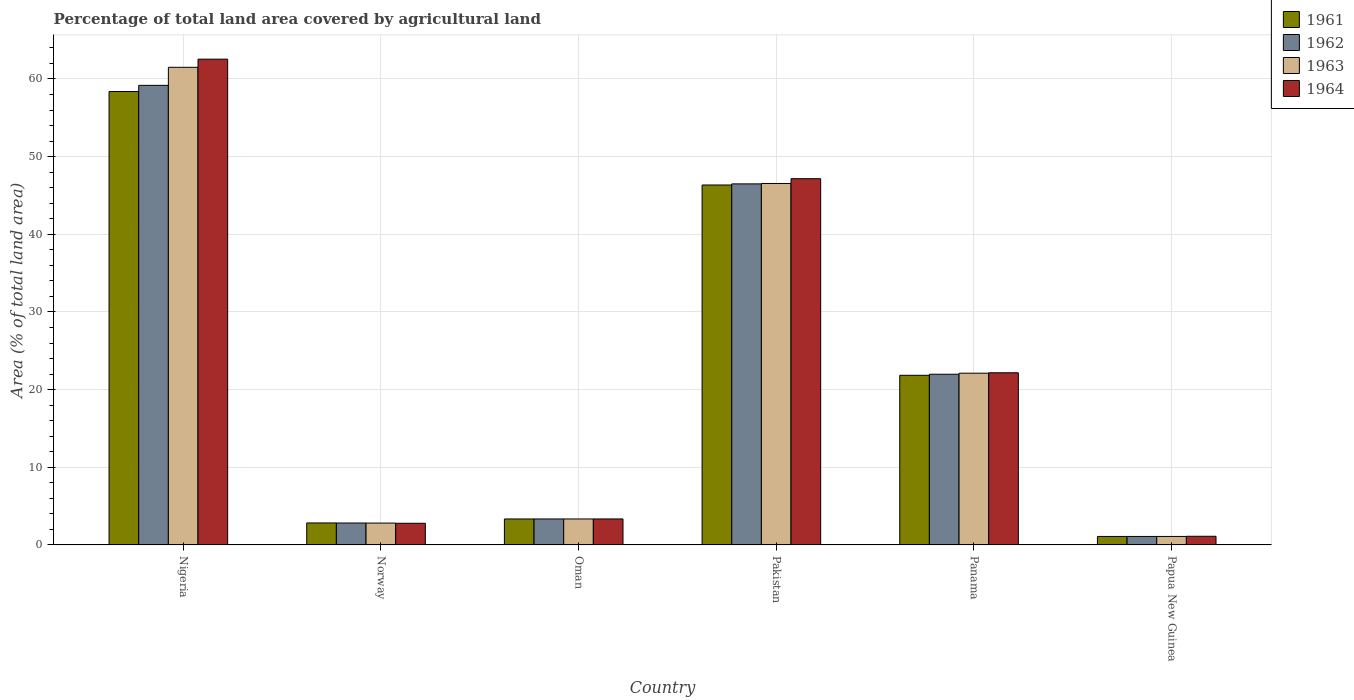How many different coloured bars are there?
Provide a short and direct response. 4. How many bars are there on the 3rd tick from the left?
Offer a terse response. 4. How many bars are there on the 2nd tick from the right?
Ensure brevity in your answer.  4. What is the label of the 6th group of bars from the left?
Your answer should be very brief. Papua New Guinea. What is the percentage of agricultural land in 1962 in Norway?
Ensure brevity in your answer.  2.82. Across all countries, what is the maximum percentage of agricultural land in 1962?
Your answer should be very brief. 59.18. Across all countries, what is the minimum percentage of agricultural land in 1962?
Your answer should be compact. 1.09. In which country was the percentage of agricultural land in 1961 maximum?
Provide a short and direct response. Nigeria. In which country was the percentage of agricultural land in 1962 minimum?
Provide a succinct answer. Papua New Guinea. What is the total percentage of agricultural land in 1963 in the graph?
Provide a succinct answer. 137.42. What is the difference between the percentage of agricultural land in 1961 in Oman and that in Papua New Guinea?
Your answer should be very brief. 2.25. What is the difference between the percentage of agricultural land in 1962 in Nigeria and the percentage of agricultural land in 1961 in Panama?
Ensure brevity in your answer.  37.34. What is the average percentage of agricultural land in 1962 per country?
Your answer should be compact. 22.49. What is the difference between the percentage of agricultural land of/in 1964 and percentage of agricultural land of/in 1963 in Pakistan?
Ensure brevity in your answer.  0.62. What is the ratio of the percentage of agricultural land in 1963 in Oman to that in Pakistan?
Offer a very short reply. 0.07. Is the difference between the percentage of agricultural land in 1964 in Norway and Oman greater than the difference between the percentage of agricultural land in 1963 in Norway and Oman?
Make the answer very short. No. What is the difference between the highest and the second highest percentage of agricultural land in 1962?
Keep it short and to the point. 37.2. What is the difference between the highest and the lowest percentage of agricultural land in 1962?
Offer a very short reply. 58.09. Is it the case that in every country, the sum of the percentage of agricultural land in 1964 and percentage of agricultural land in 1961 is greater than the sum of percentage of agricultural land in 1962 and percentage of agricultural land in 1963?
Make the answer very short. No. What does the 2nd bar from the left in Nigeria represents?
Offer a terse response. 1962. What does the 3rd bar from the right in Oman represents?
Offer a very short reply. 1962. What is the difference between two consecutive major ticks on the Y-axis?
Provide a short and direct response. 10. Are the values on the major ticks of Y-axis written in scientific E-notation?
Make the answer very short. No. Does the graph contain any zero values?
Provide a succinct answer. No. Does the graph contain grids?
Your answer should be compact. Yes. Where does the legend appear in the graph?
Give a very brief answer. Top right. How many legend labels are there?
Provide a succinct answer. 4. What is the title of the graph?
Offer a terse response. Percentage of total land area covered by agricultural land. Does "1972" appear as one of the legend labels in the graph?
Provide a succinct answer. No. What is the label or title of the Y-axis?
Your answer should be very brief. Area (% of total land area). What is the Area (% of total land area) of 1961 in Nigeria?
Your answer should be compact. 58.39. What is the Area (% of total land area) in 1962 in Nigeria?
Give a very brief answer. 59.18. What is the Area (% of total land area) in 1963 in Nigeria?
Offer a very short reply. 61.51. What is the Area (% of total land area) of 1964 in Nigeria?
Your answer should be compact. 62.55. What is the Area (% of total land area) of 1961 in Norway?
Give a very brief answer. 2.83. What is the Area (% of total land area) in 1962 in Norway?
Offer a terse response. 2.82. What is the Area (% of total land area) of 1963 in Norway?
Your answer should be very brief. 2.81. What is the Area (% of total land area) of 1964 in Norway?
Offer a very short reply. 2.79. What is the Area (% of total land area) of 1961 in Oman?
Offer a terse response. 3.34. What is the Area (% of total land area) in 1962 in Oman?
Your response must be concise. 3.34. What is the Area (% of total land area) of 1963 in Oman?
Your answer should be very brief. 3.34. What is the Area (% of total land area) of 1964 in Oman?
Give a very brief answer. 3.35. What is the Area (% of total land area) in 1961 in Pakistan?
Provide a succinct answer. 46.35. What is the Area (% of total land area) in 1962 in Pakistan?
Your answer should be very brief. 46.49. What is the Area (% of total land area) of 1963 in Pakistan?
Your answer should be very brief. 46.54. What is the Area (% of total land area) in 1964 in Pakistan?
Ensure brevity in your answer.  47.16. What is the Area (% of total land area) of 1961 in Panama?
Make the answer very short. 21.85. What is the Area (% of total land area) in 1962 in Panama?
Give a very brief answer. 21.98. What is the Area (% of total land area) in 1963 in Panama?
Your answer should be compact. 22.11. What is the Area (% of total land area) in 1964 in Panama?
Provide a succinct answer. 22.17. What is the Area (% of total land area) of 1961 in Papua New Guinea?
Offer a very short reply. 1.09. What is the Area (% of total land area) in 1962 in Papua New Guinea?
Keep it short and to the point. 1.09. What is the Area (% of total land area) of 1963 in Papua New Guinea?
Your answer should be very brief. 1.09. What is the Area (% of total land area) of 1964 in Papua New Guinea?
Your answer should be very brief. 1.12. Across all countries, what is the maximum Area (% of total land area) of 1961?
Offer a terse response. 58.39. Across all countries, what is the maximum Area (% of total land area) in 1962?
Provide a short and direct response. 59.18. Across all countries, what is the maximum Area (% of total land area) in 1963?
Keep it short and to the point. 61.51. Across all countries, what is the maximum Area (% of total land area) of 1964?
Make the answer very short. 62.55. Across all countries, what is the minimum Area (% of total land area) of 1961?
Keep it short and to the point. 1.09. Across all countries, what is the minimum Area (% of total land area) in 1962?
Your response must be concise. 1.09. Across all countries, what is the minimum Area (% of total land area) of 1963?
Ensure brevity in your answer.  1.09. Across all countries, what is the minimum Area (% of total land area) in 1964?
Give a very brief answer. 1.12. What is the total Area (% of total land area) in 1961 in the graph?
Ensure brevity in your answer.  133.85. What is the total Area (% of total land area) in 1962 in the graph?
Your response must be concise. 134.91. What is the total Area (% of total land area) of 1963 in the graph?
Keep it short and to the point. 137.42. What is the total Area (% of total land area) in 1964 in the graph?
Offer a terse response. 139.13. What is the difference between the Area (% of total land area) of 1961 in Nigeria and that in Norway?
Ensure brevity in your answer.  55.56. What is the difference between the Area (% of total land area) of 1962 in Nigeria and that in Norway?
Offer a very short reply. 56.36. What is the difference between the Area (% of total land area) in 1963 in Nigeria and that in Norway?
Keep it short and to the point. 58.69. What is the difference between the Area (% of total land area) of 1964 in Nigeria and that in Norway?
Offer a terse response. 59.76. What is the difference between the Area (% of total land area) in 1961 in Nigeria and that in Oman?
Your answer should be very brief. 55.04. What is the difference between the Area (% of total land area) in 1962 in Nigeria and that in Oman?
Offer a terse response. 55.84. What is the difference between the Area (% of total land area) of 1963 in Nigeria and that in Oman?
Offer a terse response. 58.16. What is the difference between the Area (% of total land area) in 1964 in Nigeria and that in Oman?
Your answer should be very brief. 59.21. What is the difference between the Area (% of total land area) of 1961 in Nigeria and that in Pakistan?
Keep it short and to the point. 12.04. What is the difference between the Area (% of total land area) in 1962 in Nigeria and that in Pakistan?
Your answer should be very brief. 12.69. What is the difference between the Area (% of total land area) in 1963 in Nigeria and that in Pakistan?
Make the answer very short. 14.96. What is the difference between the Area (% of total land area) of 1964 in Nigeria and that in Pakistan?
Provide a short and direct response. 15.39. What is the difference between the Area (% of total land area) of 1961 in Nigeria and that in Panama?
Ensure brevity in your answer.  36.54. What is the difference between the Area (% of total land area) in 1962 in Nigeria and that in Panama?
Make the answer very short. 37.2. What is the difference between the Area (% of total land area) of 1963 in Nigeria and that in Panama?
Give a very brief answer. 39.39. What is the difference between the Area (% of total land area) in 1964 in Nigeria and that in Panama?
Your response must be concise. 40.38. What is the difference between the Area (% of total land area) in 1961 in Nigeria and that in Papua New Guinea?
Your answer should be very brief. 57.29. What is the difference between the Area (% of total land area) of 1962 in Nigeria and that in Papua New Guinea?
Make the answer very short. 58.09. What is the difference between the Area (% of total land area) of 1963 in Nigeria and that in Papua New Guinea?
Ensure brevity in your answer.  60.41. What is the difference between the Area (% of total land area) of 1964 in Nigeria and that in Papua New Guinea?
Make the answer very short. 61.44. What is the difference between the Area (% of total land area) in 1961 in Norway and that in Oman?
Make the answer very short. -0.51. What is the difference between the Area (% of total land area) of 1962 in Norway and that in Oman?
Your answer should be very brief. -0.52. What is the difference between the Area (% of total land area) in 1963 in Norway and that in Oman?
Your answer should be compact. -0.53. What is the difference between the Area (% of total land area) of 1964 in Norway and that in Oman?
Your response must be concise. -0.56. What is the difference between the Area (% of total land area) of 1961 in Norway and that in Pakistan?
Your answer should be compact. -43.52. What is the difference between the Area (% of total land area) in 1962 in Norway and that in Pakistan?
Keep it short and to the point. -43.67. What is the difference between the Area (% of total land area) of 1963 in Norway and that in Pakistan?
Your answer should be very brief. -43.73. What is the difference between the Area (% of total land area) in 1964 in Norway and that in Pakistan?
Your answer should be compact. -44.37. What is the difference between the Area (% of total land area) of 1961 in Norway and that in Panama?
Offer a terse response. -19.01. What is the difference between the Area (% of total land area) in 1962 in Norway and that in Panama?
Give a very brief answer. -19.16. What is the difference between the Area (% of total land area) of 1963 in Norway and that in Panama?
Your answer should be very brief. -19.3. What is the difference between the Area (% of total land area) in 1964 in Norway and that in Panama?
Offer a very short reply. -19.38. What is the difference between the Area (% of total land area) of 1961 in Norway and that in Papua New Guinea?
Your response must be concise. 1.74. What is the difference between the Area (% of total land area) in 1962 in Norway and that in Papua New Guinea?
Give a very brief answer. 1.73. What is the difference between the Area (% of total land area) of 1963 in Norway and that in Papua New Guinea?
Give a very brief answer. 1.72. What is the difference between the Area (% of total land area) of 1964 in Norway and that in Papua New Guinea?
Offer a very short reply. 1.67. What is the difference between the Area (% of total land area) in 1961 in Oman and that in Pakistan?
Keep it short and to the point. -43.01. What is the difference between the Area (% of total land area) in 1962 in Oman and that in Pakistan?
Give a very brief answer. -43.15. What is the difference between the Area (% of total land area) in 1963 in Oman and that in Pakistan?
Your answer should be compact. -43.2. What is the difference between the Area (% of total land area) in 1964 in Oman and that in Pakistan?
Keep it short and to the point. -43.81. What is the difference between the Area (% of total land area) in 1961 in Oman and that in Panama?
Your response must be concise. -18.5. What is the difference between the Area (% of total land area) of 1962 in Oman and that in Panama?
Keep it short and to the point. -18.64. What is the difference between the Area (% of total land area) in 1963 in Oman and that in Panama?
Give a very brief answer. -18.77. What is the difference between the Area (% of total land area) in 1964 in Oman and that in Panama?
Offer a terse response. -18.82. What is the difference between the Area (% of total land area) in 1961 in Oman and that in Papua New Guinea?
Your answer should be compact. 2.25. What is the difference between the Area (% of total land area) of 1962 in Oman and that in Papua New Guinea?
Give a very brief answer. 2.25. What is the difference between the Area (% of total land area) in 1963 in Oman and that in Papua New Guinea?
Offer a terse response. 2.25. What is the difference between the Area (% of total land area) of 1964 in Oman and that in Papua New Guinea?
Keep it short and to the point. 2.23. What is the difference between the Area (% of total land area) in 1961 in Pakistan and that in Panama?
Provide a succinct answer. 24.5. What is the difference between the Area (% of total land area) of 1962 in Pakistan and that in Panama?
Ensure brevity in your answer.  24.51. What is the difference between the Area (% of total land area) in 1963 in Pakistan and that in Panama?
Your answer should be very brief. 24.43. What is the difference between the Area (% of total land area) of 1964 in Pakistan and that in Panama?
Keep it short and to the point. 24.99. What is the difference between the Area (% of total land area) in 1961 in Pakistan and that in Papua New Guinea?
Give a very brief answer. 45.26. What is the difference between the Area (% of total land area) in 1962 in Pakistan and that in Papua New Guinea?
Your answer should be very brief. 45.4. What is the difference between the Area (% of total land area) of 1963 in Pakistan and that in Papua New Guinea?
Offer a terse response. 45.45. What is the difference between the Area (% of total land area) of 1964 in Pakistan and that in Papua New Guinea?
Offer a very short reply. 46.05. What is the difference between the Area (% of total land area) of 1961 in Panama and that in Papua New Guinea?
Provide a short and direct response. 20.75. What is the difference between the Area (% of total land area) of 1962 in Panama and that in Papua New Guinea?
Give a very brief answer. 20.89. What is the difference between the Area (% of total land area) in 1963 in Panama and that in Papua New Guinea?
Make the answer very short. 21.02. What is the difference between the Area (% of total land area) in 1964 in Panama and that in Papua New Guinea?
Provide a short and direct response. 21.05. What is the difference between the Area (% of total land area) of 1961 in Nigeria and the Area (% of total land area) of 1962 in Norway?
Make the answer very short. 55.56. What is the difference between the Area (% of total land area) of 1961 in Nigeria and the Area (% of total land area) of 1963 in Norway?
Offer a terse response. 55.57. What is the difference between the Area (% of total land area) of 1961 in Nigeria and the Area (% of total land area) of 1964 in Norway?
Your response must be concise. 55.6. What is the difference between the Area (% of total land area) in 1962 in Nigeria and the Area (% of total land area) in 1963 in Norway?
Give a very brief answer. 56.37. What is the difference between the Area (% of total land area) of 1962 in Nigeria and the Area (% of total land area) of 1964 in Norway?
Your answer should be very brief. 56.39. What is the difference between the Area (% of total land area) of 1963 in Nigeria and the Area (% of total land area) of 1964 in Norway?
Keep it short and to the point. 58.72. What is the difference between the Area (% of total land area) in 1961 in Nigeria and the Area (% of total land area) in 1962 in Oman?
Provide a succinct answer. 55.04. What is the difference between the Area (% of total land area) in 1961 in Nigeria and the Area (% of total land area) in 1963 in Oman?
Keep it short and to the point. 55.04. What is the difference between the Area (% of total land area) in 1961 in Nigeria and the Area (% of total land area) in 1964 in Oman?
Give a very brief answer. 55.04. What is the difference between the Area (% of total land area) in 1962 in Nigeria and the Area (% of total land area) in 1963 in Oman?
Give a very brief answer. 55.84. What is the difference between the Area (% of total land area) of 1962 in Nigeria and the Area (% of total land area) of 1964 in Oman?
Ensure brevity in your answer.  55.83. What is the difference between the Area (% of total land area) in 1963 in Nigeria and the Area (% of total land area) in 1964 in Oman?
Keep it short and to the point. 58.16. What is the difference between the Area (% of total land area) of 1961 in Nigeria and the Area (% of total land area) of 1962 in Pakistan?
Ensure brevity in your answer.  11.89. What is the difference between the Area (% of total land area) of 1961 in Nigeria and the Area (% of total land area) of 1963 in Pakistan?
Your answer should be compact. 11.84. What is the difference between the Area (% of total land area) of 1961 in Nigeria and the Area (% of total land area) of 1964 in Pakistan?
Your response must be concise. 11.23. What is the difference between the Area (% of total land area) of 1962 in Nigeria and the Area (% of total land area) of 1963 in Pakistan?
Offer a very short reply. 12.64. What is the difference between the Area (% of total land area) in 1962 in Nigeria and the Area (% of total land area) in 1964 in Pakistan?
Your answer should be compact. 12.02. What is the difference between the Area (% of total land area) in 1963 in Nigeria and the Area (% of total land area) in 1964 in Pakistan?
Your answer should be very brief. 14.34. What is the difference between the Area (% of total land area) of 1961 in Nigeria and the Area (% of total land area) of 1962 in Panama?
Offer a very short reply. 36.41. What is the difference between the Area (% of total land area) of 1961 in Nigeria and the Area (% of total land area) of 1963 in Panama?
Your answer should be compact. 36.27. What is the difference between the Area (% of total land area) in 1961 in Nigeria and the Area (% of total land area) in 1964 in Panama?
Offer a very short reply. 36.22. What is the difference between the Area (% of total land area) of 1962 in Nigeria and the Area (% of total land area) of 1963 in Panama?
Ensure brevity in your answer.  37.07. What is the difference between the Area (% of total land area) of 1962 in Nigeria and the Area (% of total land area) of 1964 in Panama?
Provide a short and direct response. 37.01. What is the difference between the Area (% of total land area) of 1963 in Nigeria and the Area (% of total land area) of 1964 in Panama?
Provide a short and direct response. 39.34. What is the difference between the Area (% of total land area) of 1961 in Nigeria and the Area (% of total land area) of 1962 in Papua New Guinea?
Offer a terse response. 57.29. What is the difference between the Area (% of total land area) of 1961 in Nigeria and the Area (% of total land area) of 1963 in Papua New Guinea?
Your response must be concise. 57.29. What is the difference between the Area (% of total land area) of 1961 in Nigeria and the Area (% of total land area) of 1964 in Papua New Guinea?
Provide a succinct answer. 57.27. What is the difference between the Area (% of total land area) in 1962 in Nigeria and the Area (% of total land area) in 1963 in Papua New Guinea?
Make the answer very short. 58.09. What is the difference between the Area (% of total land area) in 1962 in Nigeria and the Area (% of total land area) in 1964 in Papua New Guinea?
Provide a succinct answer. 58.07. What is the difference between the Area (% of total land area) in 1963 in Nigeria and the Area (% of total land area) in 1964 in Papua New Guinea?
Provide a short and direct response. 60.39. What is the difference between the Area (% of total land area) in 1961 in Norway and the Area (% of total land area) in 1962 in Oman?
Make the answer very short. -0.51. What is the difference between the Area (% of total land area) of 1961 in Norway and the Area (% of total land area) of 1963 in Oman?
Provide a succinct answer. -0.51. What is the difference between the Area (% of total land area) of 1961 in Norway and the Area (% of total land area) of 1964 in Oman?
Give a very brief answer. -0.52. What is the difference between the Area (% of total land area) in 1962 in Norway and the Area (% of total land area) in 1963 in Oman?
Your answer should be compact. -0.52. What is the difference between the Area (% of total land area) of 1962 in Norway and the Area (% of total land area) of 1964 in Oman?
Keep it short and to the point. -0.52. What is the difference between the Area (% of total land area) of 1963 in Norway and the Area (% of total land area) of 1964 in Oman?
Make the answer very short. -0.53. What is the difference between the Area (% of total land area) of 1961 in Norway and the Area (% of total land area) of 1962 in Pakistan?
Ensure brevity in your answer.  -43.66. What is the difference between the Area (% of total land area) of 1961 in Norway and the Area (% of total land area) of 1963 in Pakistan?
Your answer should be compact. -43.71. What is the difference between the Area (% of total land area) of 1961 in Norway and the Area (% of total land area) of 1964 in Pakistan?
Keep it short and to the point. -44.33. What is the difference between the Area (% of total land area) in 1962 in Norway and the Area (% of total land area) in 1963 in Pakistan?
Ensure brevity in your answer.  -43.72. What is the difference between the Area (% of total land area) of 1962 in Norway and the Area (% of total land area) of 1964 in Pakistan?
Give a very brief answer. -44.34. What is the difference between the Area (% of total land area) of 1963 in Norway and the Area (% of total land area) of 1964 in Pakistan?
Make the answer very short. -44.35. What is the difference between the Area (% of total land area) in 1961 in Norway and the Area (% of total land area) in 1962 in Panama?
Ensure brevity in your answer.  -19.15. What is the difference between the Area (% of total land area) in 1961 in Norway and the Area (% of total land area) in 1963 in Panama?
Give a very brief answer. -19.28. What is the difference between the Area (% of total land area) in 1961 in Norway and the Area (% of total land area) in 1964 in Panama?
Offer a terse response. -19.34. What is the difference between the Area (% of total land area) of 1962 in Norway and the Area (% of total land area) of 1963 in Panama?
Offer a terse response. -19.29. What is the difference between the Area (% of total land area) in 1962 in Norway and the Area (% of total land area) in 1964 in Panama?
Offer a terse response. -19.35. What is the difference between the Area (% of total land area) of 1963 in Norway and the Area (% of total land area) of 1964 in Panama?
Ensure brevity in your answer.  -19.35. What is the difference between the Area (% of total land area) of 1961 in Norway and the Area (% of total land area) of 1962 in Papua New Guinea?
Your answer should be compact. 1.74. What is the difference between the Area (% of total land area) of 1961 in Norway and the Area (% of total land area) of 1963 in Papua New Guinea?
Your answer should be compact. 1.74. What is the difference between the Area (% of total land area) in 1961 in Norway and the Area (% of total land area) in 1964 in Papua New Guinea?
Ensure brevity in your answer.  1.72. What is the difference between the Area (% of total land area) in 1962 in Norway and the Area (% of total land area) in 1963 in Papua New Guinea?
Offer a very short reply. 1.73. What is the difference between the Area (% of total land area) of 1962 in Norway and the Area (% of total land area) of 1964 in Papua New Guinea?
Offer a very short reply. 1.71. What is the difference between the Area (% of total land area) in 1963 in Norway and the Area (% of total land area) in 1964 in Papua New Guinea?
Your answer should be compact. 1.7. What is the difference between the Area (% of total land area) of 1961 in Oman and the Area (% of total land area) of 1962 in Pakistan?
Your answer should be compact. -43.15. What is the difference between the Area (% of total land area) in 1961 in Oman and the Area (% of total land area) in 1963 in Pakistan?
Provide a short and direct response. -43.2. What is the difference between the Area (% of total land area) in 1961 in Oman and the Area (% of total land area) in 1964 in Pakistan?
Keep it short and to the point. -43.82. What is the difference between the Area (% of total land area) of 1962 in Oman and the Area (% of total land area) of 1963 in Pakistan?
Your answer should be very brief. -43.2. What is the difference between the Area (% of total land area) of 1962 in Oman and the Area (% of total land area) of 1964 in Pakistan?
Offer a very short reply. -43.82. What is the difference between the Area (% of total land area) in 1963 in Oman and the Area (% of total land area) in 1964 in Pakistan?
Provide a short and direct response. -43.82. What is the difference between the Area (% of total land area) of 1961 in Oman and the Area (% of total land area) of 1962 in Panama?
Give a very brief answer. -18.64. What is the difference between the Area (% of total land area) in 1961 in Oman and the Area (% of total land area) in 1963 in Panama?
Ensure brevity in your answer.  -18.77. What is the difference between the Area (% of total land area) in 1961 in Oman and the Area (% of total land area) in 1964 in Panama?
Provide a succinct answer. -18.82. What is the difference between the Area (% of total land area) in 1962 in Oman and the Area (% of total land area) in 1963 in Panama?
Ensure brevity in your answer.  -18.77. What is the difference between the Area (% of total land area) in 1962 in Oman and the Area (% of total land area) in 1964 in Panama?
Your answer should be compact. -18.82. What is the difference between the Area (% of total land area) of 1963 in Oman and the Area (% of total land area) of 1964 in Panama?
Make the answer very short. -18.82. What is the difference between the Area (% of total land area) in 1961 in Oman and the Area (% of total land area) in 1962 in Papua New Guinea?
Your answer should be very brief. 2.25. What is the difference between the Area (% of total land area) in 1961 in Oman and the Area (% of total land area) in 1963 in Papua New Guinea?
Your answer should be compact. 2.25. What is the difference between the Area (% of total land area) of 1961 in Oman and the Area (% of total land area) of 1964 in Papua New Guinea?
Offer a very short reply. 2.23. What is the difference between the Area (% of total land area) in 1962 in Oman and the Area (% of total land area) in 1963 in Papua New Guinea?
Ensure brevity in your answer.  2.25. What is the difference between the Area (% of total land area) of 1962 in Oman and the Area (% of total land area) of 1964 in Papua New Guinea?
Provide a succinct answer. 2.23. What is the difference between the Area (% of total land area) of 1963 in Oman and the Area (% of total land area) of 1964 in Papua New Guinea?
Offer a terse response. 2.23. What is the difference between the Area (% of total land area) of 1961 in Pakistan and the Area (% of total land area) of 1962 in Panama?
Make the answer very short. 24.37. What is the difference between the Area (% of total land area) in 1961 in Pakistan and the Area (% of total land area) in 1963 in Panama?
Provide a succinct answer. 24.23. What is the difference between the Area (% of total land area) in 1961 in Pakistan and the Area (% of total land area) in 1964 in Panama?
Ensure brevity in your answer.  24.18. What is the difference between the Area (% of total land area) in 1962 in Pakistan and the Area (% of total land area) in 1963 in Panama?
Give a very brief answer. 24.38. What is the difference between the Area (% of total land area) in 1962 in Pakistan and the Area (% of total land area) in 1964 in Panama?
Your answer should be very brief. 24.32. What is the difference between the Area (% of total land area) in 1963 in Pakistan and the Area (% of total land area) in 1964 in Panama?
Ensure brevity in your answer.  24.38. What is the difference between the Area (% of total land area) in 1961 in Pakistan and the Area (% of total land area) in 1962 in Papua New Guinea?
Provide a succinct answer. 45.26. What is the difference between the Area (% of total land area) in 1961 in Pakistan and the Area (% of total land area) in 1963 in Papua New Guinea?
Your response must be concise. 45.26. What is the difference between the Area (% of total land area) of 1961 in Pakistan and the Area (% of total land area) of 1964 in Papua New Guinea?
Provide a short and direct response. 45.23. What is the difference between the Area (% of total land area) in 1962 in Pakistan and the Area (% of total land area) in 1963 in Papua New Guinea?
Keep it short and to the point. 45.4. What is the difference between the Area (% of total land area) in 1962 in Pakistan and the Area (% of total land area) in 1964 in Papua New Guinea?
Make the answer very short. 45.38. What is the difference between the Area (% of total land area) of 1963 in Pakistan and the Area (% of total land area) of 1964 in Papua New Guinea?
Provide a succinct answer. 45.43. What is the difference between the Area (% of total land area) of 1961 in Panama and the Area (% of total land area) of 1962 in Papua New Guinea?
Offer a very short reply. 20.75. What is the difference between the Area (% of total land area) in 1961 in Panama and the Area (% of total land area) in 1963 in Papua New Guinea?
Give a very brief answer. 20.75. What is the difference between the Area (% of total land area) of 1961 in Panama and the Area (% of total land area) of 1964 in Papua New Guinea?
Make the answer very short. 20.73. What is the difference between the Area (% of total land area) of 1962 in Panama and the Area (% of total land area) of 1963 in Papua New Guinea?
Give a very brief answer. 20.89. What is the difference between the Area (% of total land area) in 1962 in Panama and the Area (% of total land area) in 1964 in Papua New Guinea?
Provide a succinct answer. 20.86. What is the difference between the Area (% of total land area) of 1963 in Panama and the Area (% of total land area) of 1964 in Papua New Guinea?
Offer a very short reply. 21. What is the average Area (% of total land area) in 1961 per country?
Your response must be concise. 22.31. What is the average Area (% of total land area) of 1962 per country?
Provide a succinct answer. 22.49. What is the average Area (% of total land area) in 1963 per country?
Keep it short and to the point. 22.9. What is the average Area (% of total land area) of 1964 per country?
Your response must be concise. 23.19. What is the difference between the Area (% of total land area) in 1961 and Area (% of total land area) in 1962 in Nigeria?
Provide a succinct answer. -0.79. What is the difference between the Area (% of total land area) in 1961 and Area (% of total land area) in 1963 in Nigeria?
Make the answer very short. -3.12. What is the difference between the Area (% of total land area) of 1961 and Area (% of total land area) of 1964 in Nigeria?
Provide a short and direct response. -4.17. What is the difference between the Area (% of total land area) of 1962 and Area (% of total land area) of 1963 in Nigeria?
Provide a succinct answer. -2.32. What is the difference between the Area (% of total land area) in 1962 and Area (% of total land area) in 1964 in Nigeria?
Your answer should be compact. -3.37. What is the difference between the Area (% of total land area) in 1963 and Area (% of total land area) in 1964 in Nigeria?
Give a very brief answer. -1.05. What is the difference between the Area (% of total land area) of 1961 and Area (% of total land area) of 1962 in Norway?
Give a very brief answer. 0.01. What is the difference between the Area (% of total land area) in 1961 and Area (% of total land area) in 1963 in Norway?
Keep it short and to the point. 0.02. What is the difference between the Area (% of total land area) in 1961 and Area (% of total land area) in 1964 in Norway?
Ensure brevity in your answer.  0.04. What is the difference between the Area (% of total land area) in 1962 and Area (% of total land area) in 1963 in Norway?
Make the answer very short. 0.01. What is the difference between the Area (% of total land area) of 1962 and Area (% of total land area) of 1964 in Norway?
Ensure brevity in your answer.  0.03. What is the difference between the Area (% of total land area) of 1963 and Area (% of total land area) of 1964 in Norway?
Offer a very short reply. 0.02. What is the difference between the Area (% of total land area) in 1961 and Area (% of total land area) in 1963 in Oman?
Offer a very short reply. 0. What is the difference between the Area (% of total land area) of 1961 and Area (% of total land area) of 1964 in Oman?
Provide a succinct answer. -0. What is the difference between the Area (% of total land area) in 1962 and Area (% of total land area) in 1963 in Oman?
Your answer should be very brief. 0. What is the difference between the Area (% of total land area) of 1962 and Area (% of total land area) of 1964 in Oman?
Your answer should be compact. -0. What is the difference between the Area (% of total land area) in 1963 and Area (% of total land area) in 1964 in Oman?
Your answer should be compact. -0. What is the difference between the Area (% of total land area) of 1961 and Area (% of total land area) of 1962 in Pakistan?
Ensure brevity in your answer.  -0.14. What is the difference between the Area (% of total land area) in 1961 and Area (% of total land area) in 1963 in Pakistan?
Ensure brevity in your answer.  -0.19. What is the difference between the Area (% of total land area) in 1961 and Area (% of total land area) in 1964 in Pakistan?
Ensure brevity in your answer.  -0.81. What is the difference between the Area (% of total land area) in 1962 and Area (% of total land area) in 1963 in Pakistan?
Provide a succinct answer. -0.05. What is the difference between the Area (% of total land area) in 1962 and Area (% of total land area) in 1964 in Pakistan?
Offer a very short reply. -0.67. What is the difference between the Area (% of total land area) in 1963 and Area (% of total land area) in 1964 in Pakistan?
Your answer should be compact. -0.62. What is the difference between the Area (% of total land area) of 1961 and Area (% of total land area) of 1962 in Panama?
Offer a very short reply. -0.13. What is the difference between the Area (% of total land area) of 1961 and Area (% of total land area) of 1963 in Panama?
Your response must be concise. -0.27. What is the difference between the Area (% of total land area) of 1961 and Area (% of total land area) of 1964 in Panama?
Your response must be concise. -0.32. What is the difference between the Area (% of total land area) of 1962 and Area (% of total land area) of 1963 in Panama?
Keep it short and to the point. -0.13. What is the difference between the Area (% of total land area) of 1962 and Area (% of total land area) of 1964 in Panama?
Make the answer very short. -0.19. What is the difference between the Area (% of total land area) of 1963 and Area (% of total land area) of 1964 in Panama?
Give a very brief answer. -0.05. What is the difference between the Area (% of total land area) of 1961 and Area (% of total land area) of 1963 in Papua New Guinea?
Offer a very short reply. 0. What is the difference between the Area (% of total land area) in 1961 and Area (% of total land area) in 1964 in Papua New Guinea?
Offer a very short reply. -0.02. What is the difference between the Area (% of total land area) in 1962 and Area (% of total land area) in 1963 in Papua New Guinea?
Ensure brevity in your answer.  0. What is the difference between the Area (% of total land area) in 1962 and Area (% of total land area) in 1964 in Papua New Guinea?
Provide a succinct answer. -0.02. What is the difference between the Area (% of total land area) in 1963 and Area (% of total land area) in 1964 in Papua New Guinea?
Offer a very short reply. -0.02. What is the ratio of the Area (% of total land area) in 1961 in Nigeria to that in Norway?
Your answer should be compact. 20.62. What is the ratio of the Area (% of total land area) in 1962 in Nigeria to that in Norway?
Offer a very short reply. 20.97. What is the ratio of the Area (% of total land area) of 1963 in Nigeria to that in Norway?
Give a very brief answer. 21.85. What is the ratio of the Area (% of total land area) of 1964 in Nigeria to that in Norway?
Offer a terse response. 22.42. What is the ratio of the Area (% of total land area) of 1961 in Nigeria to that in Oman?
Offer a terse response. 17.46. What is the ratio of the Area (% of total land area) of 1962 in Nigeria to that in Oman?
Ensure brevity in your answer.  17.7. What is the ratio of the Area (% of total land area) in 1963 in Nigeria to that in Oman?
Provide a succinct answer. 18.39. What is the ratio of the Area (% of total land area) of 1964 in Nigeria to that in Oman?
Your answer should be very brief. 18.69. What is the ratio of the Area (% of total land area) in 1961 in Nigeria to that in Pakistan?
Your answer should be very brief. 1.26. What is the ratio of the Area (% of total land area) of 1962 in Nigeria to that in Pakistan?
Give a very brief answer. 1.27. What is the ratio of the Area (% of total land area) of 1963 in Nigeria to that in Pakistan?
Your response must be concise. 1.32. What is the ratio of the Area (% of total land area) in 1964 in Nigeria to that in Pakistan?
Offer a terse response. 1.33. What is the ratio of the Area (% of total land area) in 1961 in Nigeria to that in Panama?
Ensure brevity in your answer.  2.67. What is the ratio of the Area (% of total land area) of 1962 in Nigeria to that in Panama?
Your answer should be very brief. 2.69. What is the ratio of the Area (% of total land area) of 1963 in Nigeria to that in Panama?
Give a very brief answer. 2.78. What is the ratio of the Area (% of total land area) in 1964 in Nigeria to that in Panama?
Provide a short and direct response. 2.82. What is the ratio of the Area (% of total land area) of 1961 in Nigeria to that in Papua New Guinea?
Offer a terse response. 53.42. What is the ratio of the Area (% of total land area) of 1962 in Nigeria to that in Papua New Guinea?
Give a very brief answer. 54.14. What is the ratio of the Area (% of total land area) in 1963 in Nigeria to that in Papua New Guinea?
Your answer should be compact. 56.27. What is the ratio of the Area (% of total land area) in 1964 in Nigeria to that in Papua New Guinea?
Keep it short and to the point. 56.09. What is the ratio of the Area (% of total land area) of 1961 in Norway to that in Oman?
Your answer should be compact. 0.85. What is the ratio of the Area (% of total land area) in 1962 in Norway to that in Oman?
Make the answer very short. 0.84. What is the ratio of the Area (% of total land area) of 1963 in Norway to that in Oman?
Your answer should be compact. 0.84. What is the ratio of the Area (% of total land area) in 1964 in Norway to that in Oman?
Your response must be concise. 0.83. What is the ratio of the Area (% of total land area) of 1961 in Norway to that in Pakistan?
Provide a succinct answer. 0.06. What is the ratio of the Area (% of total land area) of 1962 in Norway to that in Pakistan?
Your response must be concise. 0.06. What is the ratio of the Area (% of total land area) of 1963 in Norway to that in Pakistan?
Ensure brevity in your answer.  0.06. What is the ratio of the Area (% of total land area) in 1964 in Norway to that in Pakistan?
Provide a short and direct response. 0.06. What is the ratio of the Area (% of total land area) in 1961 in Norway to that in Panama?
Your answer should be compact. 0.13. What is the ratio of the Area (% of total land area) in 1962 in Norway to that in Panama?
Offer a very short reply. 0.13. What is the ratio of the Area (% of total land area) of 1963 in Norway to that in Panama?
Provide a succinct answer. 0.13. What is the ratio of the Area (% of total land area) in 1964 in Norway to that in Panama?
Give a very brief answer. 0.13. What is the ratio of the Area (% of total land area) of 1961 in Norway to that in Papua New Guinea?
Your answer should be compact. 2.59. What is the ratio of the Area (% of total land area) of 1962 in Norway to that in Papua New Guinea?
Your response must be concise. 2.58. What is the ratio of the Area (% of total land area) of 1963 in Norway to that in Papua New Guinea?
Offer a terse response. 2.57. What is the ratio of the Area (% of total land area) in 1964 in Norway to that in Papua New Guinea?
Provide a succinct answer. 2.5. What is the ratio of the Area (% of total land area) of 1961 in Oman to that in Pakistan?
Your answer should be compact. 0.07. What is the ratio of the Area (% of total land area) of 1962 in Oman to that in Pakistan?
Offer a very short reply. 0.07. What is the ratio of the Area (% of total land area) of 1963 in Oman to that in Pakistan?
Your response must be concise. 0.07. What is the ratio of the Area (% of total land area) of 1964 in Oman to that in Pakistan?
Keep it short and to the point. 0.07. What is the ratio of the Area (% of total land area) in 1961 in Oman to that in Panama?
Your answer should be very brief. 0.15. What is the ratio of the Area (% of total land area) in 1962 in Oman to that in Panama?
Your response must be concise. 0.15. What is the ratio of the Area (% of total land area) in 1963 in Oman to that in Panama?
Your answer should be very brief. 0.15. What is the ratio of the Area (% of total land area) in 1964 in Oman to that in Panama?
Offer a very short reply. 0.15. What is the ratio of the Area (% of total land area) of 1961 in Oman to that in Papua New Guinea?
Your response must be concise. 3.06. What is the ratio of the Area (% of total land area) of 1962 in Oman to that in Papua New Guinea?
Keep it short and to the point. 3.06. What is the ratio of the Area (% of total land area) of 1963 in Oman to that in Papua New Guinea?
Offer a terse response. 3.06. What is the ratio of the Area (% of total land area) of 1964 in Oman to that in Papua New Guinea?
Offer a terse response. 3. What is the ratio of the Area (% of total land area) in 1961 in Pakistan to that in Panama?
Make the answer very short. 2.12. What is the ratio of the Area (% of total land area) of 1962 in Pakistan to that in Panama?
Ensure brevity in your answer.  2.12. What is the ratio of the Area (% of total land area) of 1963 in Pakistan to that in Panama?
Provide a short and direct response. 2.1. What is the ratio of the Area (% of total land area) of 1964 in Pakistan to that in Panama?
Offer a very short reply. 2.13. What is the ratio of the Area (% of total land area) of 1961 in Pakistan to that in Papua New Guinea?
Make the answer very short. 42.4. What is the ratio of the Area (% of total land area) in 1962 in Pakistan to that in Papua New Guinea?
Offer a very short reply. 42.53. What is the ratio of the Area (% of total land area) in 1963 in Pakistan to that in Papua New Guinea?
Your response must be concise. 42.58. What is the ratio of the Area (% of total land area) in 1964 in Pakistan to that in Papua New Guinea?
Provide a short and direct response. 42.29. What is the ratio of the Area (% of total land area) of 1961 in Panama to that in Papua New Guinea?
Your answer should be very brief. 19.99. What is the ratio of the Area (% of total land area) of 1962 in Panama to that in Papua New Guinea?
Give a very brief answer. 20.11. What is the ratio of the Area (% of total land area) of 1963 in Panama to that in Papua New Guinea?
Provide a short and direct response. 20.23. What is the ratio of the Area (% of total land area) of 1964 in Panama to that in Papua New Guinea?
Provide a succinct answer. 19.88. What is the difference between the highest and the second highest Area (% of total land area) in 1961?
Your response must be concise. 12.04. What is the difference between the highest and the second highest Area (% of total land area) in 1962?
Give a very brief answer. 12.69. What is the difference between the highest and the second highest Area (% of total land area) in 1963?
Give a very brief answer. 14.96. What is the difference between the highest and the second highest Area (% of total land area) of 1964?
Provide a short and direct response. 15.39. What is the difference between the highest and the lowest Area (% of total land area) in 1961?
Provide a succinct answer. 57.29. What is the difference between the highest and the lowest Area (% of total land area) in 1962?
Keep it short and to the point. 58.09. What is the difference between the highest and the lowest Area (% of total land area) of 1963?
Ensure brevity in your answer.  60.41. What is the difference between the highest and the lowest Area (% of total land area) in 1964?
Your answer should be compact. 61.44. 